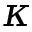<formula> <loc_0><loc_0><loc_500><loc_500>\kappa</formula> 